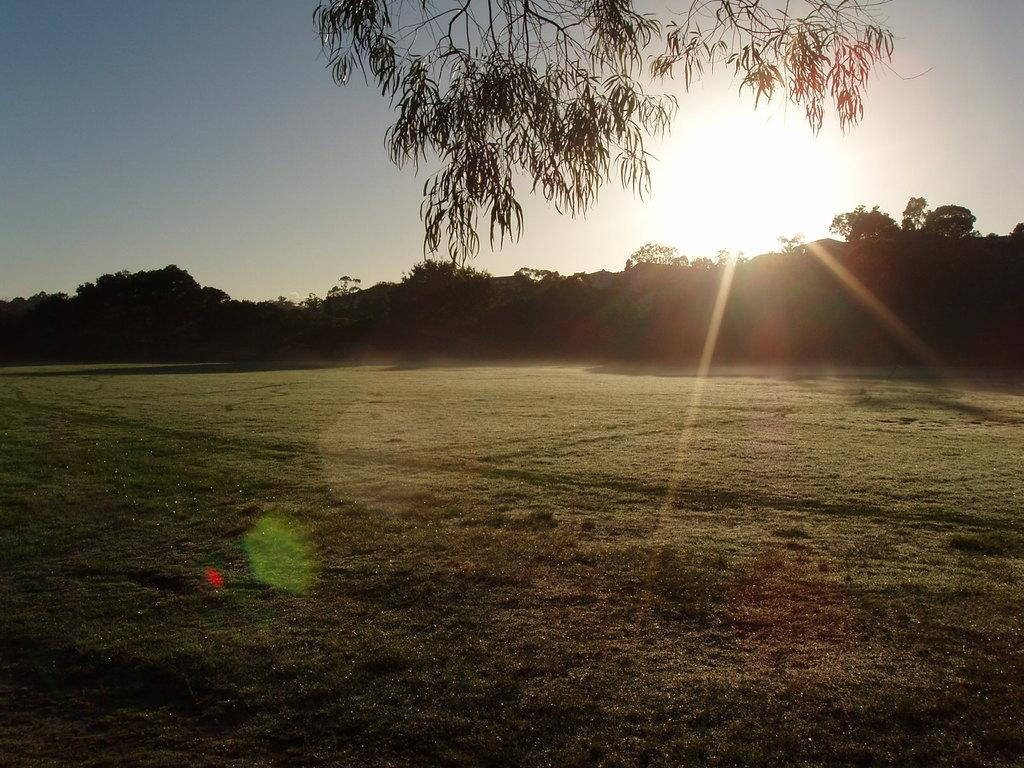What type of vegetation can be seen in the image? There are trees in the image. What time of day is depicted in the image? There is a sunset in the image, suggesting that it is late afternoon or early evening. What is visible at the bottom of the image? There is ground visible at the bottom of the image. What type of doctor is present in the image? There is no doctor present in the image; it features trees and a sunset. What type of business is being conducted in the image? There is no business activity depicted in the image; it features trees and a sunset. 